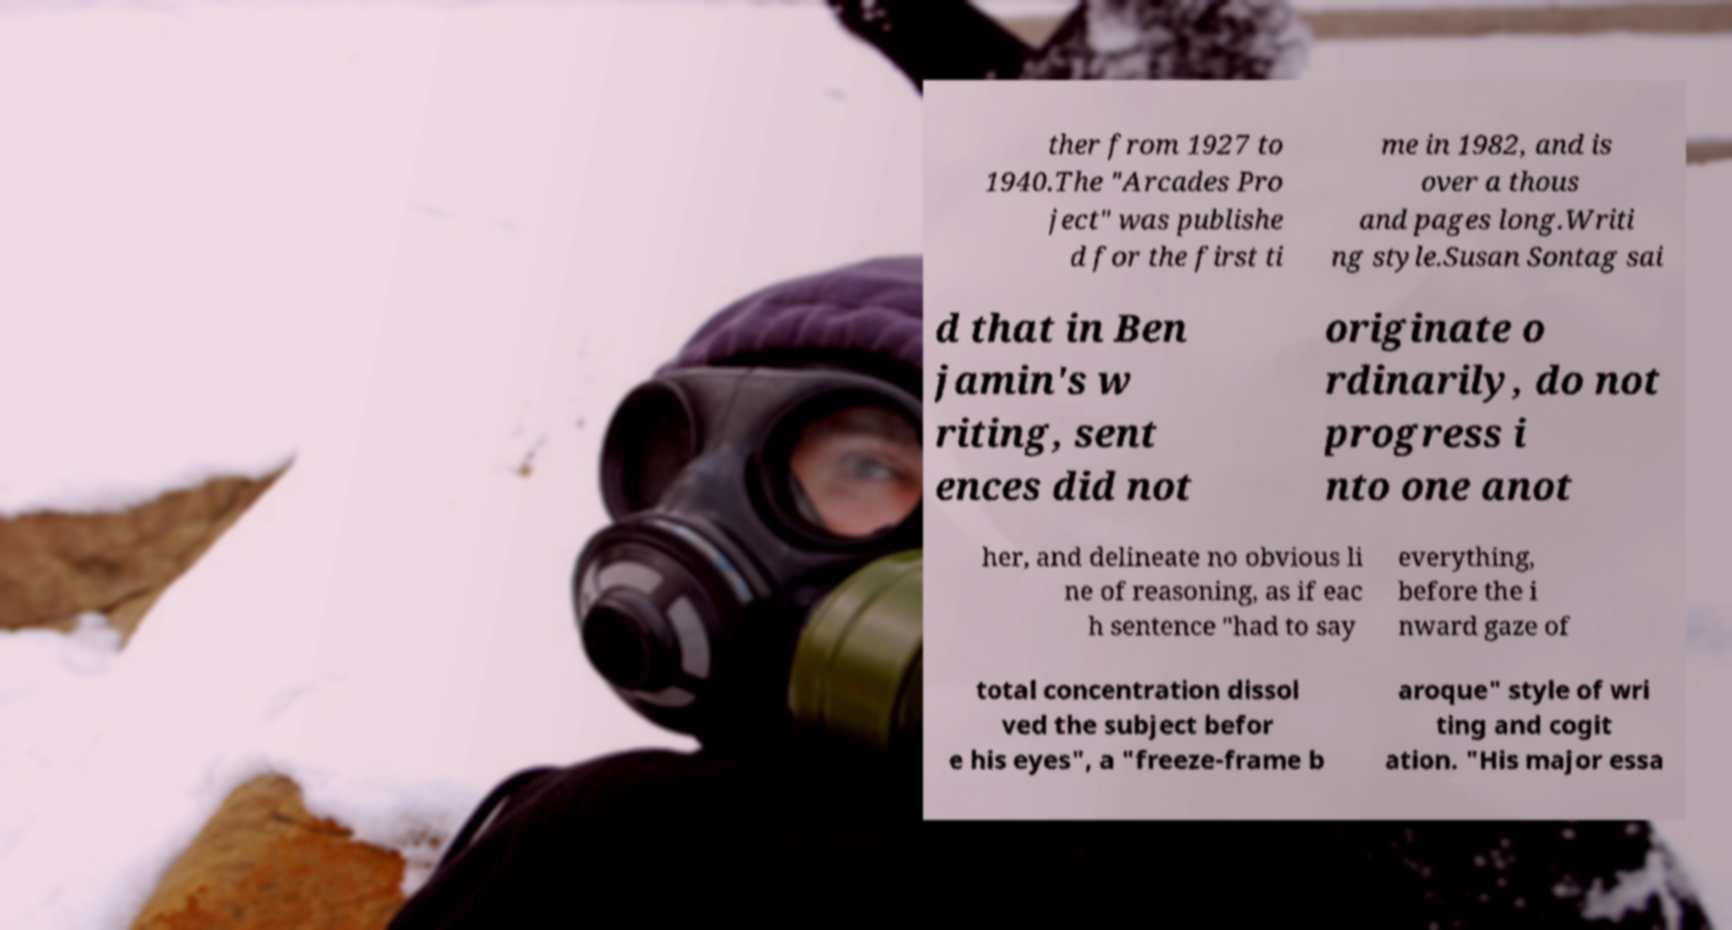Can you read and provide the text displayed in the image?This photo seems to have some interesting text. Can you extract and type it out for me? ther from 1927 to 1940.The "Arcades Pro ject" was publishe d for the first ti me in 1982, and is over a thous and pages long.Writi ng style.Susan Sontag sai d that in Ben jamin's w riting, sent ences did not originate o rdinarily, do not progress i nto one anot her, and delineate no obvious li ne of reasoning, as if eac h sentence "had to say everything, before the i nward gaze of total concentration dissol ved the subject befor e his eyes", a "freeze-frame b aroque" style of wri ting and cogit ation. "His major essa 